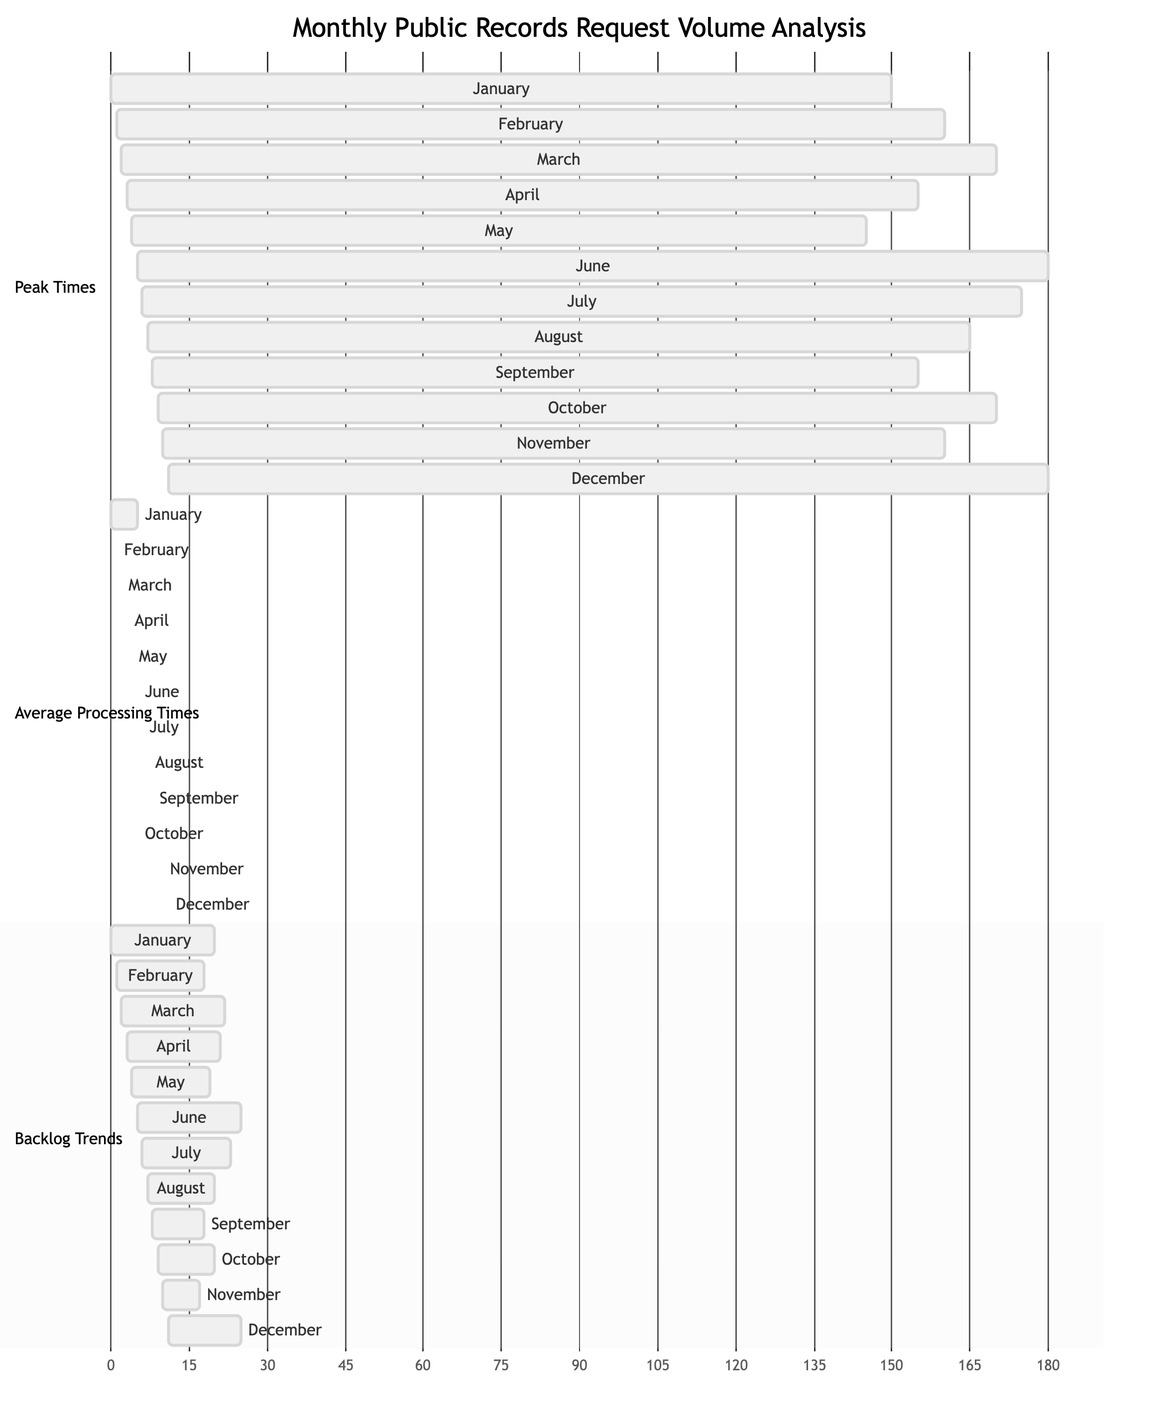What is the peak month for public records requests? The diagram indicates that the peak month for public records requests is June, with a total volume of 180 requests.
Answer: June What is the average processing time for March? The chart shows that the average processing time for March is 5.2 days.
Answer: 5.2 Which month shows the highest backlog trends? By reviewing the backlog trends section, it can be seen that June has the highest backlog with 25 requests.
Answer: June How many months had an average processing time of less than 5 days? Looking at the average processing times, four months (February, May, August, and November) had processing times below 5 days.
Answer: 4 What was the backlog trend in November? According to the backlog trends section, in November the backlog was 17 requests.
Answer: 17 Which month had the lowest public records request volume? The diagram reveals that May had the lowest request volume, with 145 requests.
Answer: May What is the average request processing time across the year? To find the average, we sum all monthly processing times (5 + 4.8 + 5.2 + 4.9 + 4.6 + 5.3 + 5.1 + 4.7 + 4.8 + 5 + 4.9 + 5.2) and divide by 12. This results in an average of approximately 5 days.
Answer: 5 How did the backlog trend change from February to March? The backlog decreased from 18 requests in February to 22 requests in March, indicating an increase in backlog.
Answer: Increase Which month had a higher average processing time, June or December? In June, the average processing time was 5.3 days, while in December it was 5.2 days, indicating June had a higher processing time.
Answer: June 